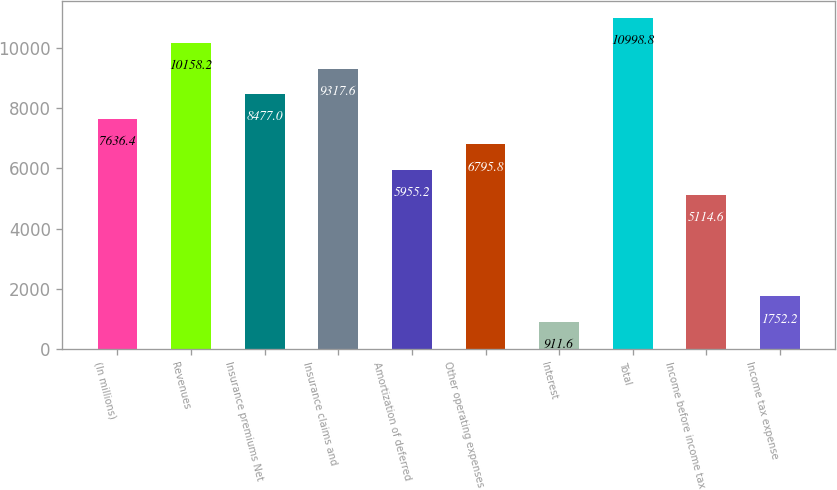Convert chart to OTSL. <chart><loc_0><loc_0><loc_500><loc_500><bar_chart><fcel>(In millions)<fcel>Revenues<fcel>Insurance premiums Net<fcel>Insurance claims and<fcel>Amortization of deferred<fcel>Other operating expenses<fcel>Interest<fcel>Total<fcel>Income before income tax<fcel>Income tax expense<nl><fcel>7636.4<fcel>10158.2<fcel>8477<fcel>9317.6<fcel>5955.2<fcel>6795.8<fcel>911.6<fcel>10998.8<fcel>5114.6<fcel>1752.2<nl></chart> 